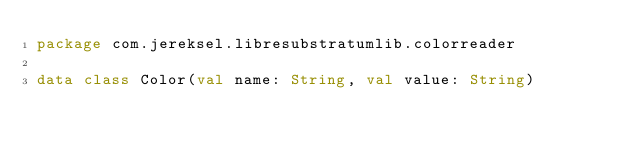Convert code to text. <code><loc_0><loc_0><loc_500><loc_500><_Kotlin_>package com.jereksel.libresubstratumlib.colorreader

data class Color(val name: String, val value: String)</code> 